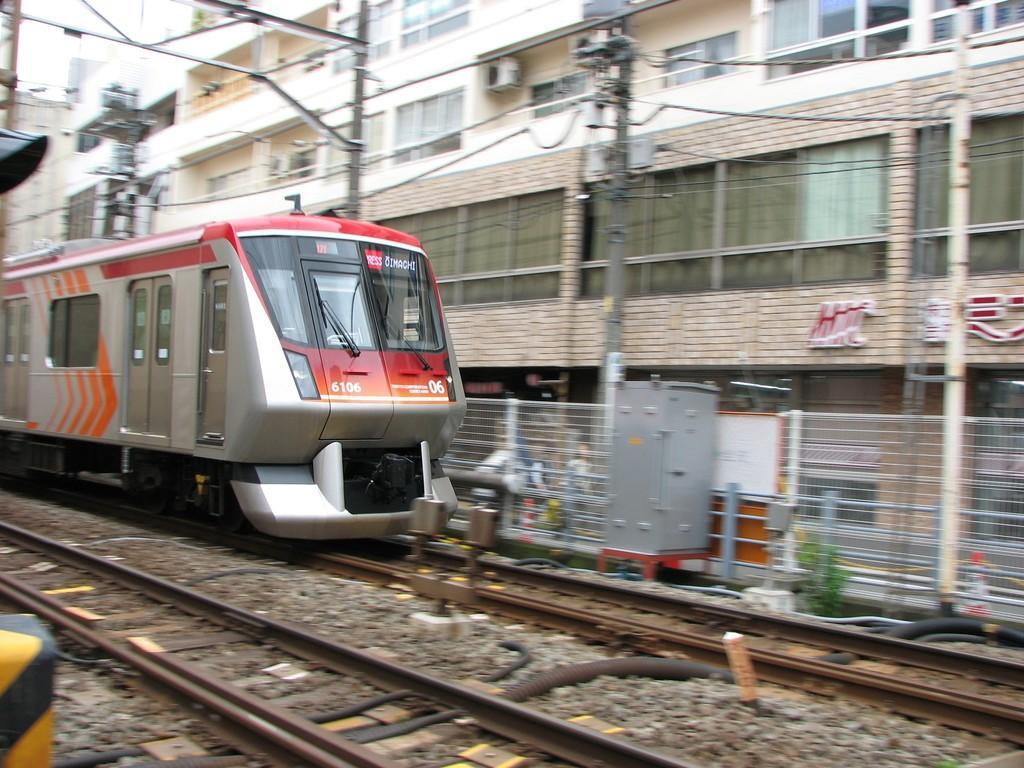In one or two sentences, can you explain what this image depicts? There is a train on the track. Here we can see a metal box, poles, wires, fence, and buildings. 